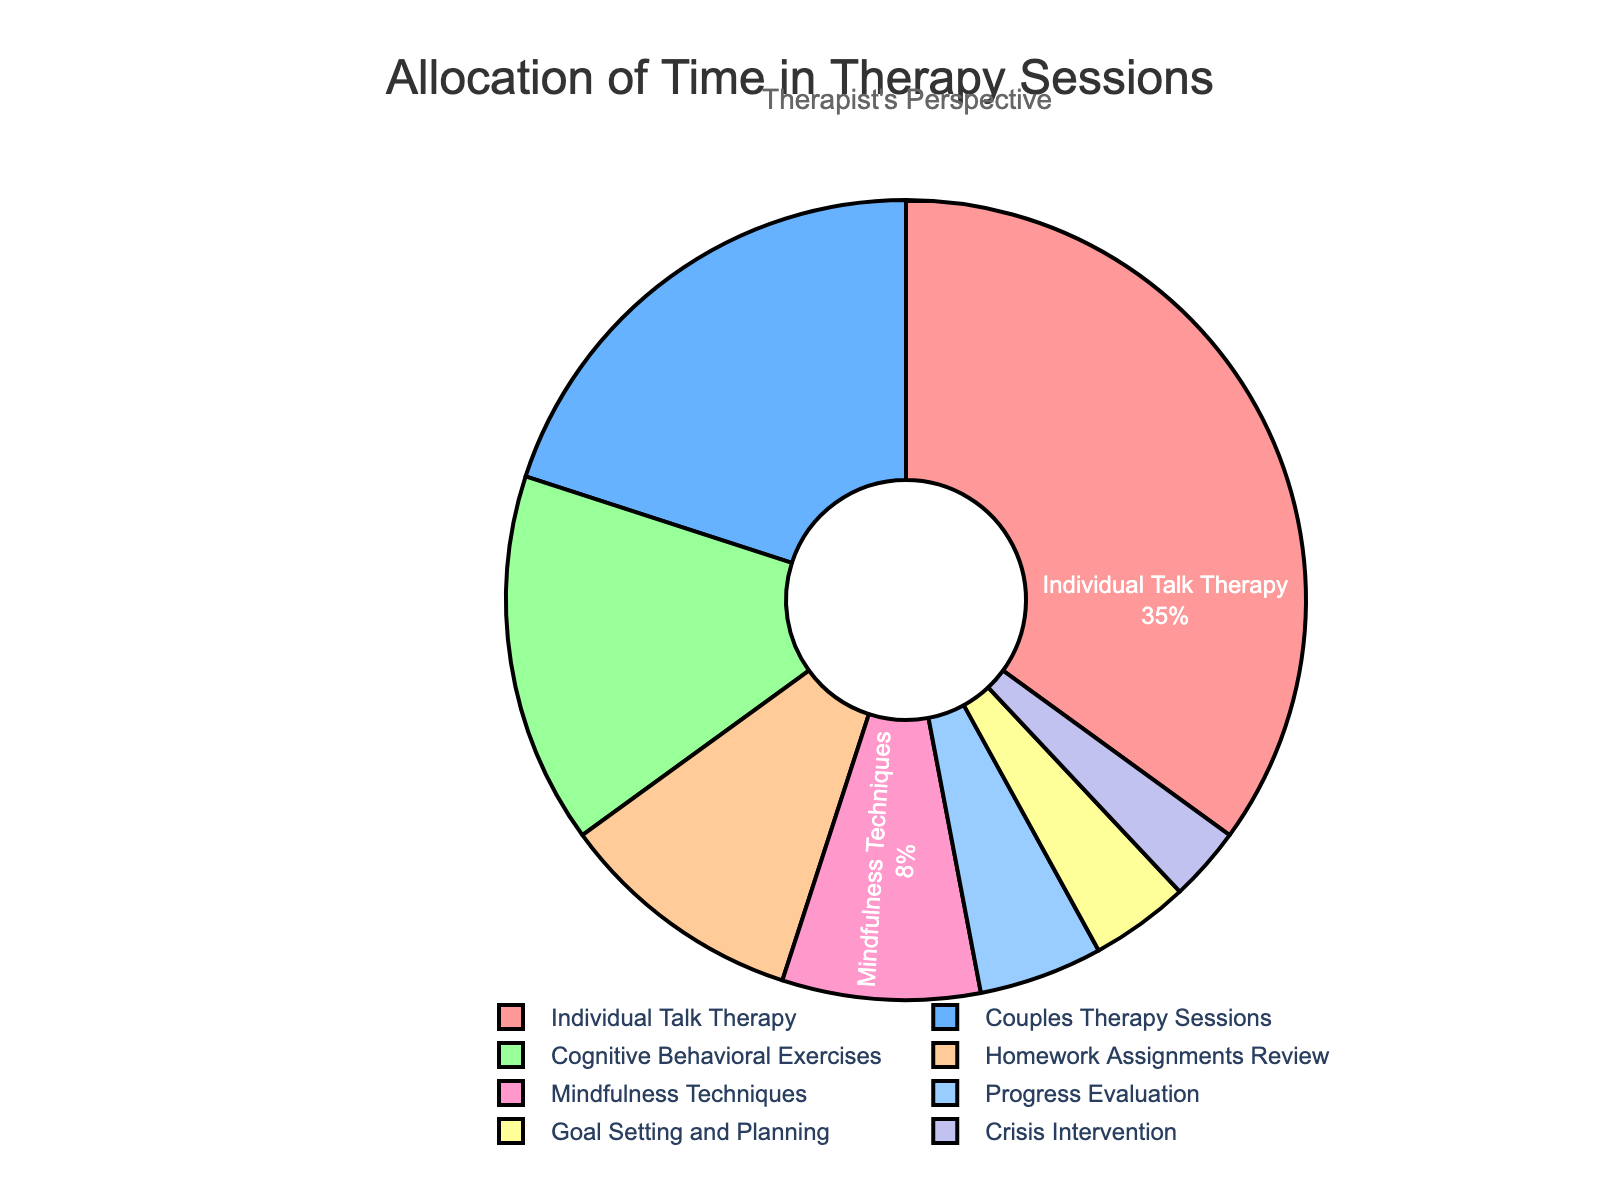What percentage of the therapy time is allocated to Individual Talk Therapy and Cognitive Behavioral Exercises combined? Add the percentage of Individual Talk Therapy (35%) to the percentage of Cognitive Behavioral Exercises (15%): 35% + 15% = 50%
Answer: 50% Which aspect of therapy takes up more time, Couples Therapy Sessions or Mindfulness Techniques? Compare the percentage allocated to Couples Therapy Sessions (20%) with the percentage allocated to Mindfulness Techniques (8%): 20% is greater than 8%
Answer: Couples Therapy Sessions What is the difference in the percentage of time allocated to Homework Assignments Review and Crisis Intervention? Subtract the percentage of time for Crisis Intervention (3%) from Homework Assignments Review (10%): 10% - 3% = 7%
Answer: 7% What percentage of the therapy time is allocated to activities other than Individual Talk Therapy? Subtract the percentage allocated to Individual Talk Therapy (35%) from the total (100%): 100% - 35% = 65%
Answer: 65% Are any aspects of therapy allocated the same percentage of time? Review each percentage value and compare: no two aspects have the same percentage.
Answer: No Which therapy aspect is represented by the blue color? Identify the blue-colored section from the legend or chart labels, which corresponds to the 20% allocated to Couples Therapy Sessions
Answer: Couples Therapy Sessions How much more time is spent on Progress Evaluation compared to Goal Setting and Planning? Subtract the percentage allocated to Goal Setting and Planning (4%) from the percentage allocated to Progress Evaluation (5%): 5% - 4% = 1%
Answer: 1% If 1 hour represents 100% of the time, how many minutes are spent on Mindfulness Techniques? Since 8% of the time is allocated to Mindfulness Techniques and 1 hour = 60 minutes, calculate: 60 * 0.08 = 4.8 minutes
Answer: 4.8 minutes What fraction of the therapy session is spent on Crisis Intervention? The percentage for Crisis Intervention is 3%, which can be expressed as a fraction: 3/100 = 3/100
Answer: 3/100 